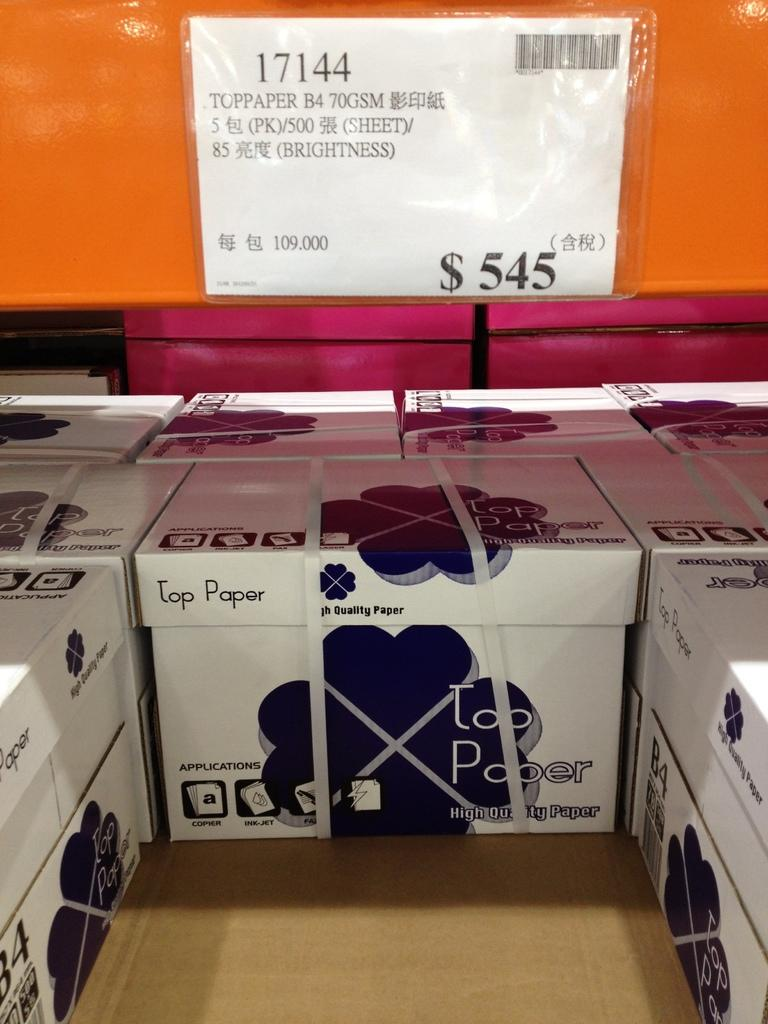<image>
Provide a brief description of the given image. Toppaper B4 70GSM that contains a 5 pack of 500 sheets. 